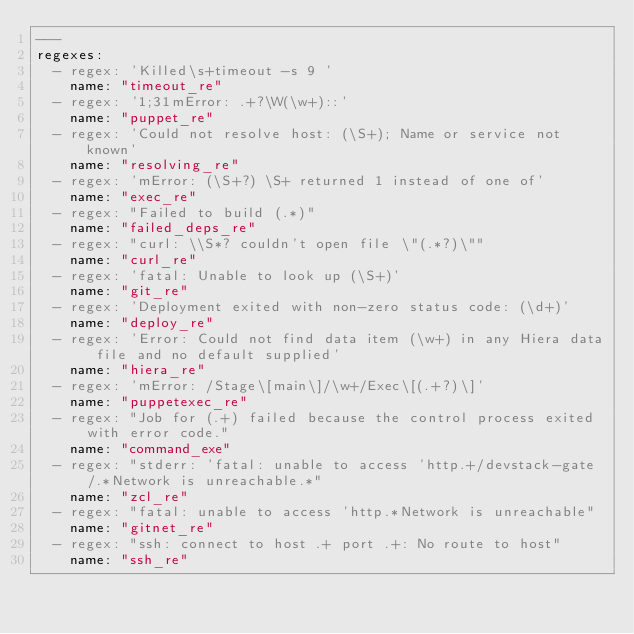<code> <loc_0><loc_0><loc_500><loc_500><_YAML_>---
regexes:
  - regex: 'Killed\s+timeout -s 9 '
    name: "timeout_re"
  - regex: '1;31mError: .+?\W(\w+)::'
    name: "puppet_re"
  - regex: 'Could not resolve host: (\S+); Name or service not known'
    name: "resolving_re"
  - regex: 'mError: (\S+?) \S+ returned 1 instead of one of'
    name: "exec_re"
  - regex: "Failed to build (.*)"
    name: "failed_deps_re"
  - regex: "curl: \\S*? couldn't open file \"(.*?)\""
    name: "curl_re"
  - regex: 'fatal: Unable to look up (\S+)'
    name: "git_re"
  - regex: 'Deployment exited with non-zero status code: (\d+)'
    name: "deploy_re"
  - regex: 'Error: Could not find data item (\w+) in any Hiera data file and no default supplied'
    name: "hiera_re"
  - regex: 'mError: /Stage\[main\]/\w+/Exec\[(.+?)\]'
    name: "puppetexec_re"
  - regex: "Job for (.+) failed because the control process exited with error code."
    name: "command_exe"
  - regex: "stderr: 'fatal: unable to access 'http.+/devstack-gate/.*Network is unreachable.*"
    name: "zcl_re"
  - regex: "fatal: unable to access 'http.*Network is unreachable"
    name: "gitnet_re"
  - regex: "ssh: connect to host .+ port .+: No route to host"
    name: "ssh_re"</code> 